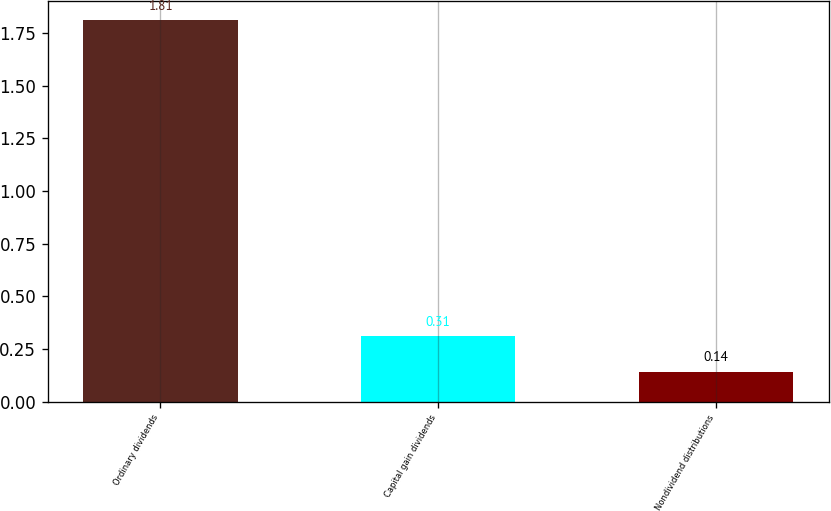Convert chart to OTSL. <chart><loc_0><loc_0><loc_500><loc_500><bar_chart><fcel>Ordinary dividends<fcel>Capital gain dividends<fcel>Nondividend distributions<nl><fcel>1.81<fcel>0.31<fcel>0.14<nl></chart> 